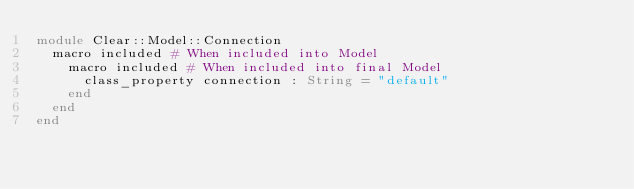Convert code to text. <code><loc_0><loc_0><loc_500><loc_500><_Crystal_>module Clear::Model::Connection
  macro included # When included into Model
    macro included # When included into final Model
      class_property connection : String = "default"
    end
  end
end
</code> 